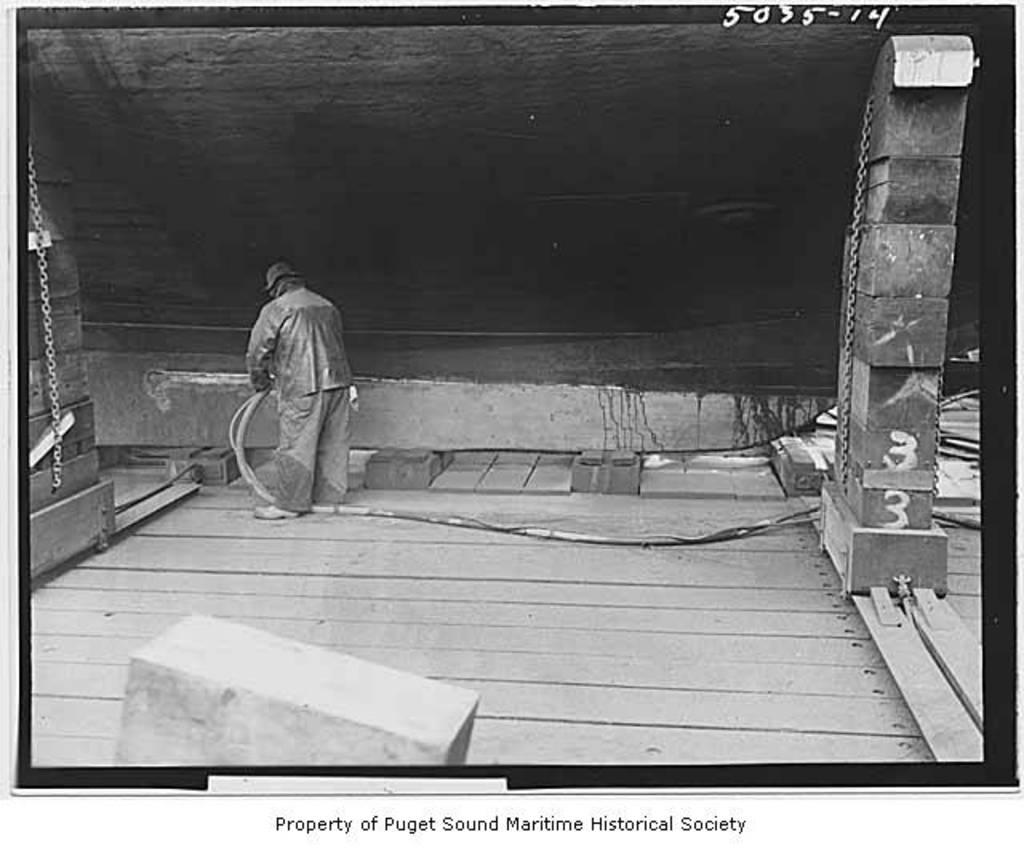What is the main subject of the image? There is a person standing in the image. What objects can be seen in the image besides the person? There is a pipe and a chain visible in the image. What can be seen in the background of the image? There is a wall in the background of the image. Is there any text present in the image? Yes, there is some text visible at the bottom of the image. What advice does the person's dad give them in the image? There is no indication in the image that the person's dad is present or giving any advice. What color is the sky in the image? The provided facts do not mention the sky, so we cannot determine its color from the image. 